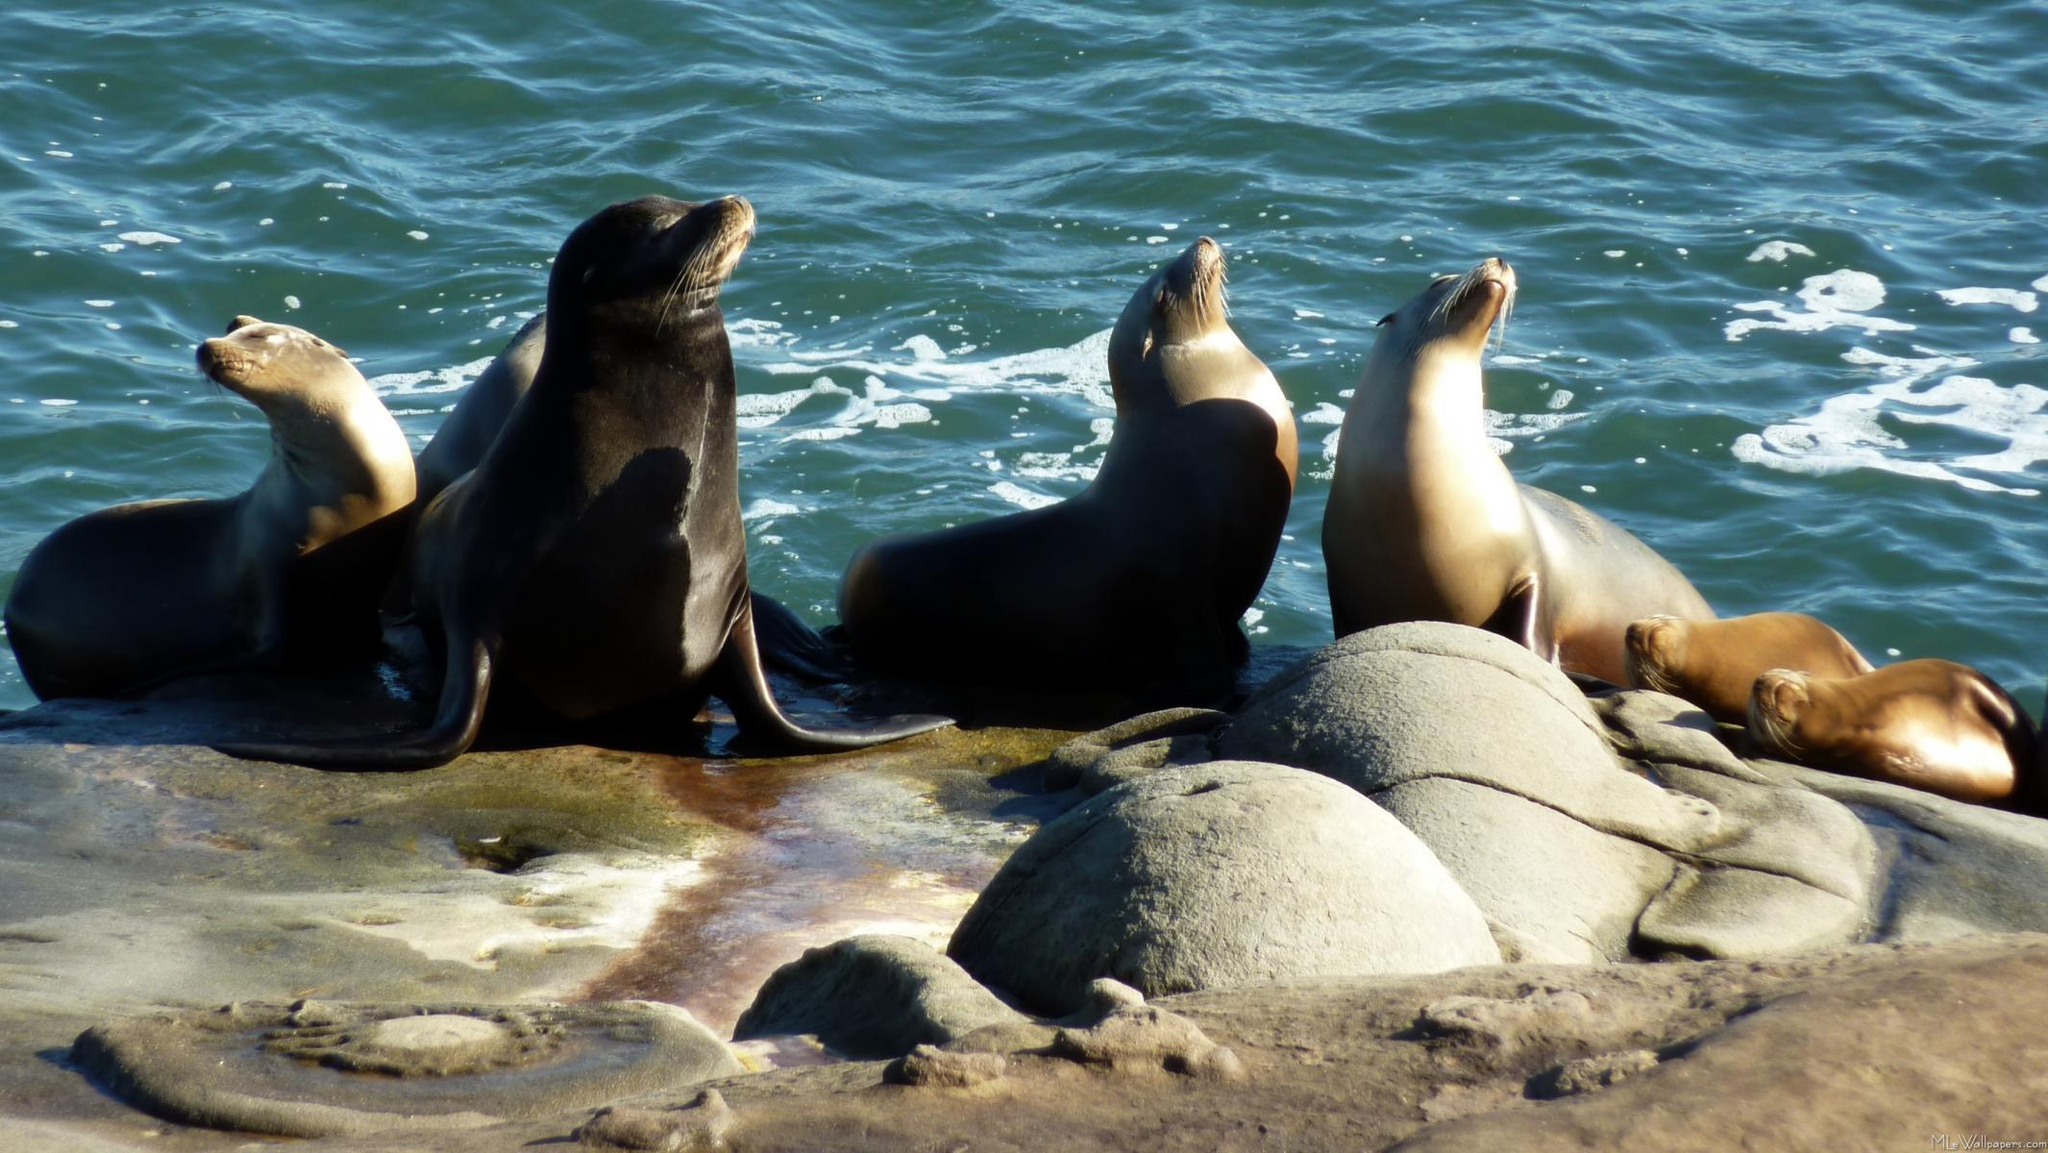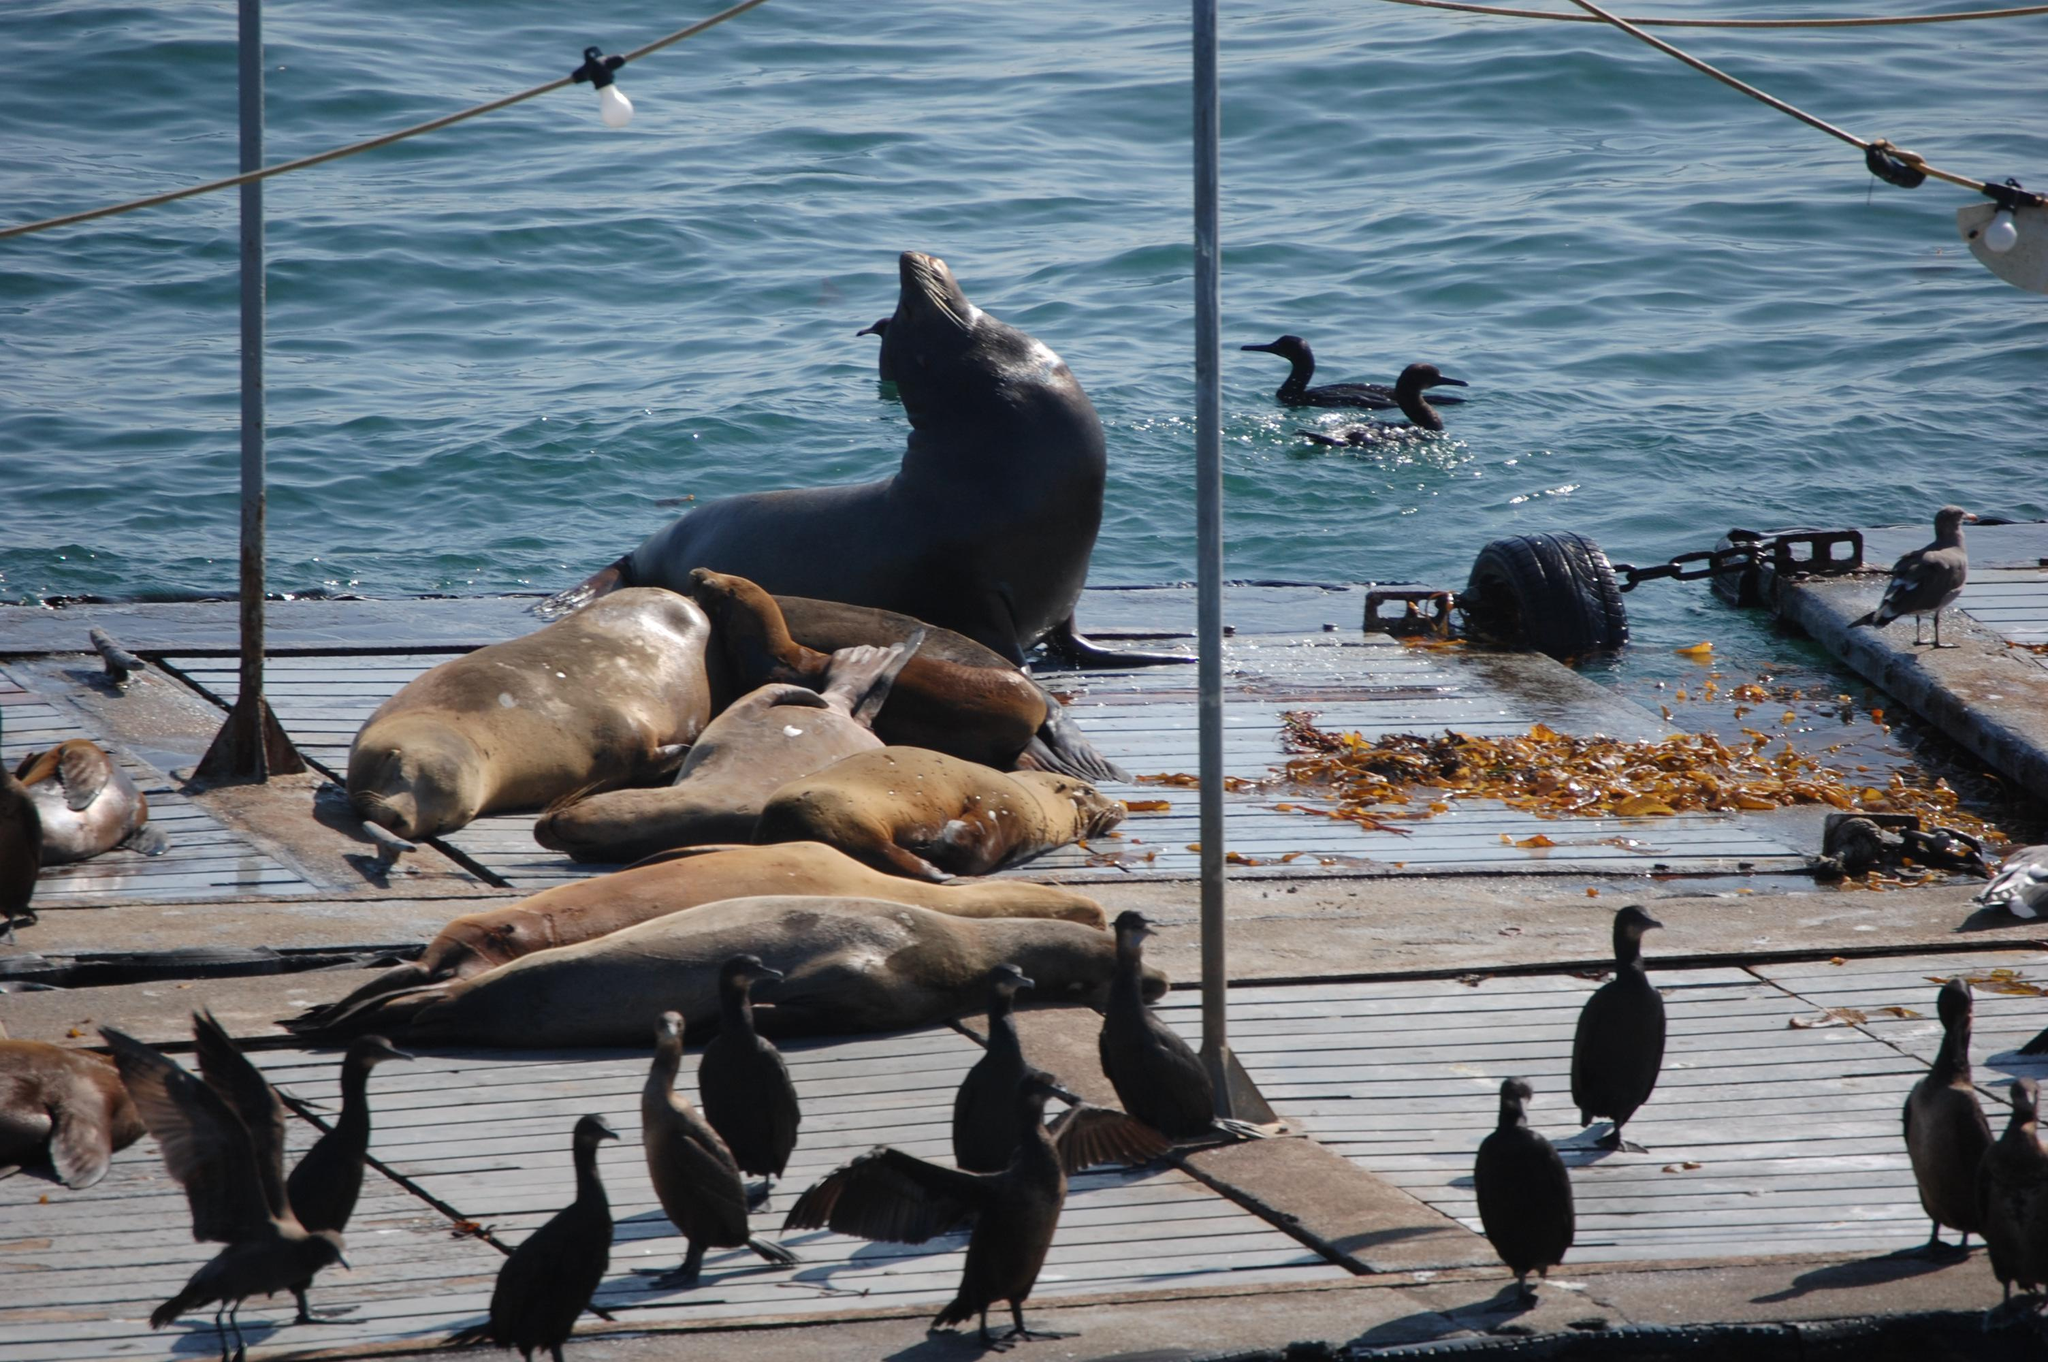The first image is the image on the left, the second image is the image on the right. Given the left and right images, does the statement "An image shows multiple seals lying on a plank-look manmade structure." hold true? Answer yes or no. Yes. 